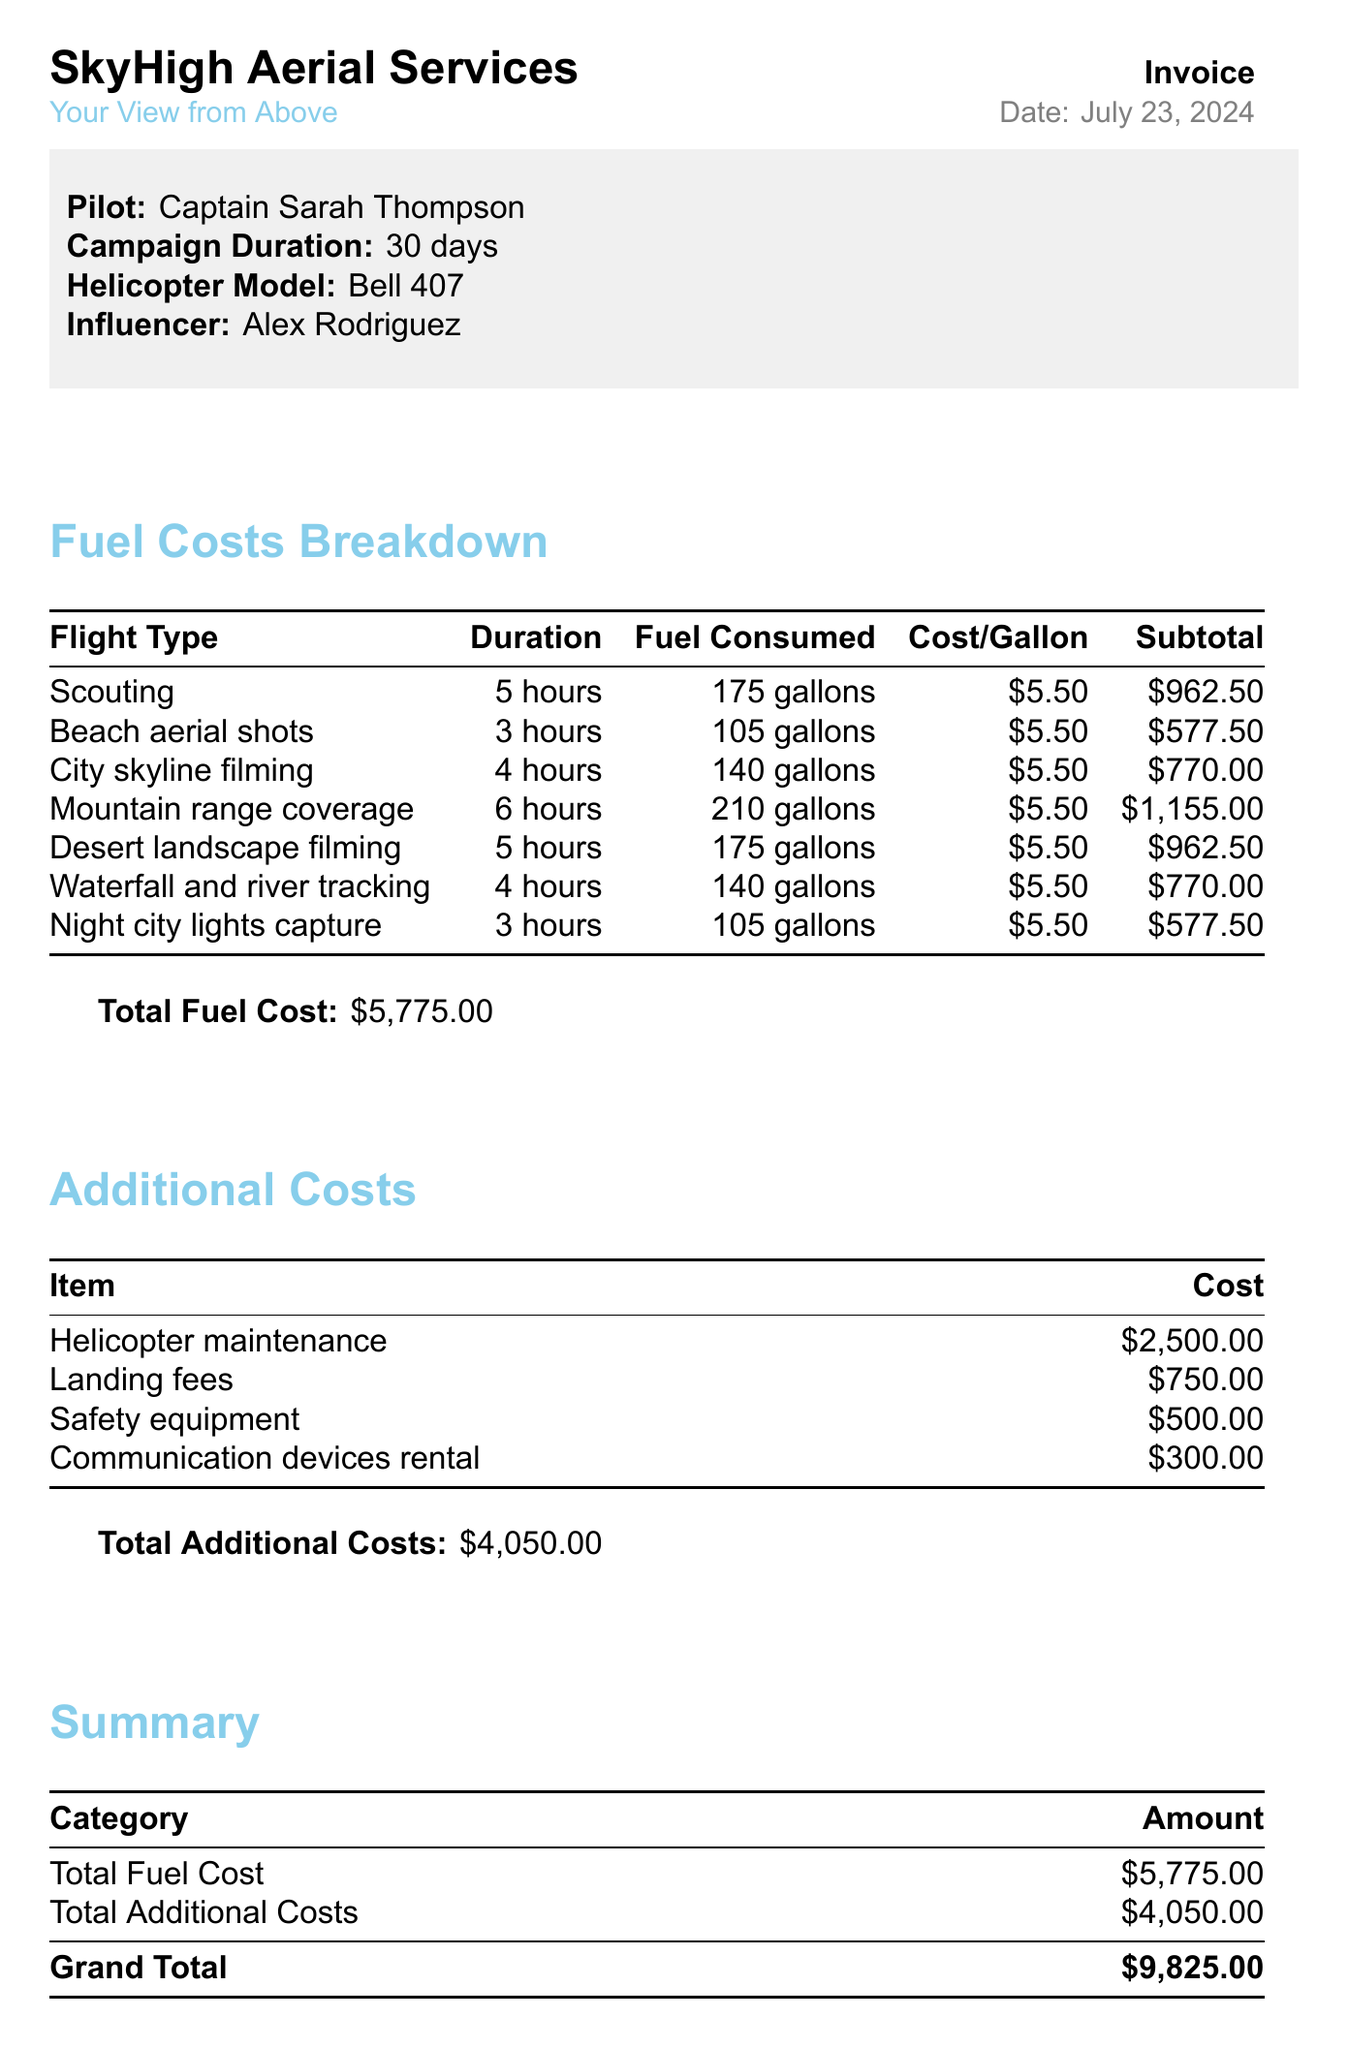What is the pilot's name? The pilot's name is mentioned at the top of the invoice document.
Answer: Captain Sarah Thompson How many gallons of fuel were consumed for the Night city lights capture flight? This information can be found in the fuel costs breakdown section of the document.
Answer: 105 gallons What is the total fuel cost? The total fuel cost is provided at the end of the fuel costs breakdown section.
Answer: $5,775.00 What is the duration of the Mountain range coverage flight? The duration is specified in the detailed breakdown of fuel costs by flight type.
Answer: 6 hours How much is the cost for safety equipment? The cost for safety equipment is listed under the additional costs section.
Answer: $500.00 What is the grand total of the invoice? The grand total is calculated from the total fuel cost and total additional costs.
Answer: $9,825.00 What flight type had the highest fuel consumed? The breakdown of flights shows the fuel consumed for each flight type, indicating which was the highest.
Answer: Mountain range coverage What are the payment terms for the invoice? The payment terms are explicitly mentioned in the notes section of the document.
Answer: Due within 30 days of invoice date How many additional costs are listed in the invoice? The number of additional costs can be counted from the corresponding section in the document.
Answer: 4 